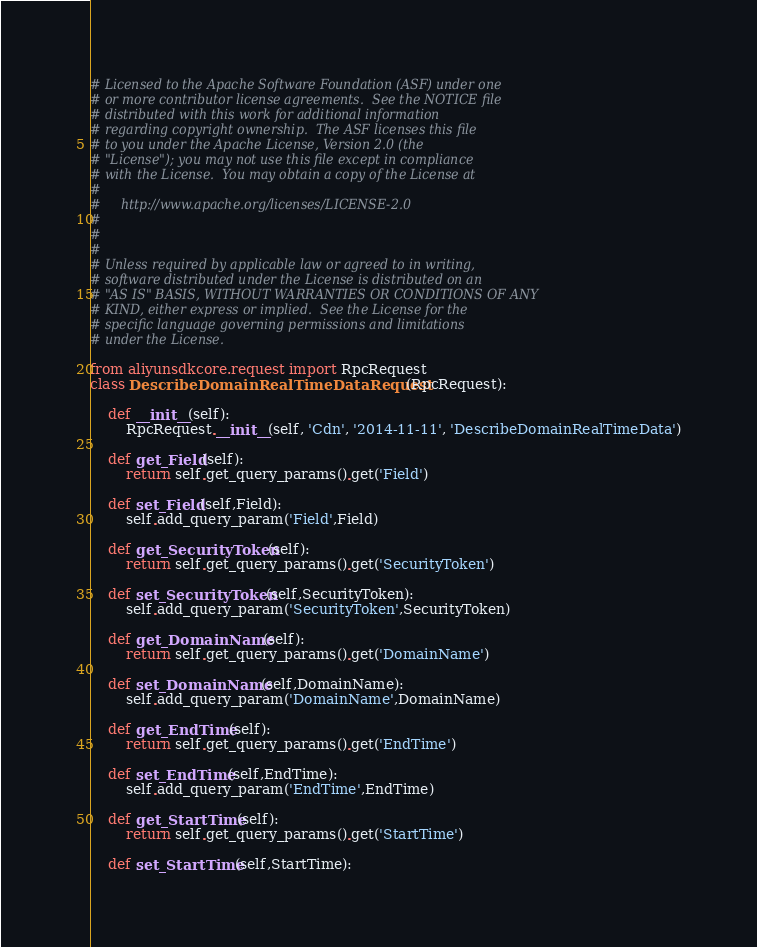Convert code to text. <code><loc_0><loc_0><loc_500><loc_500><_Python_># Licensed to the Apache Software Foundation (ASF) under one
# or more contributor license agreements.  See the NOTICE file
# distributed with this work for additional information
# regarding copyright ownership.  The ASF licenses this file
# to you under the Apache License, Version 2.0 (the
# "License"); you may not use this file except in compliance
# with the License.  You may obtain a copy of the License at
#
#     http://www.apache.org/licenses/LICENSE-2.0
#
#
#
# Unless required by applicable law or agreed to in writing,
# software distributed under the License is distributed on an
# "AS IS" BASIS, WITHOUT WARRANTIES OR CONDITIONS OF ANY
# KIND, either express or implied.  See the License for the
# specific language governing permissions and limitations
# under the License.

from aliyunsdkcore.request import RpcRequest
class DescribeDomainRealTimeDataRequest(RpcRequest):

	def __init__(self):
		RpcRequest.__init__(self, 'Cdn', '2014-11-11', 'DescribeDomainRealTimeData')

	def get_Field(self):
		return self.get_query_params().get('Field')

	def set_Field(self,Field):
		self.add_query_param('Field',Field)

	def get_SecurityToken(self):
		return self.get_query_params().get('SecurityToken')

	def set_SecurityToken(self,SecurityToken):
		self.add_query_param('SecurityToken',SecurityToken)

	def get_DomainName(self):
		return self.get_query_params().get('DomainName')

	def set_DomainName(self,DomainName):
		self.add_query_param('DomainName',DomainName)

	def get_EndTime(self):
		return self.get_query_params().get('EndTime')

	def set_EndTime(self,EndTime):
		self.add_query_param('EndTime',EndTime)

	def get_StartTime(self):
		return self.get_query_params().get('StartTime')

	def set_StartTime(self,StartTime):</code> 